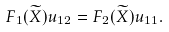Convert formula to latex. <formula><loc_0><loc_0><loc_500><loc_500>F _ { 1 } ( \widetilde { X } ) u _ { 1 2 } = F _ { 2 } ( \widetilde { X } ) u _ { 1 1 } .</formula> 